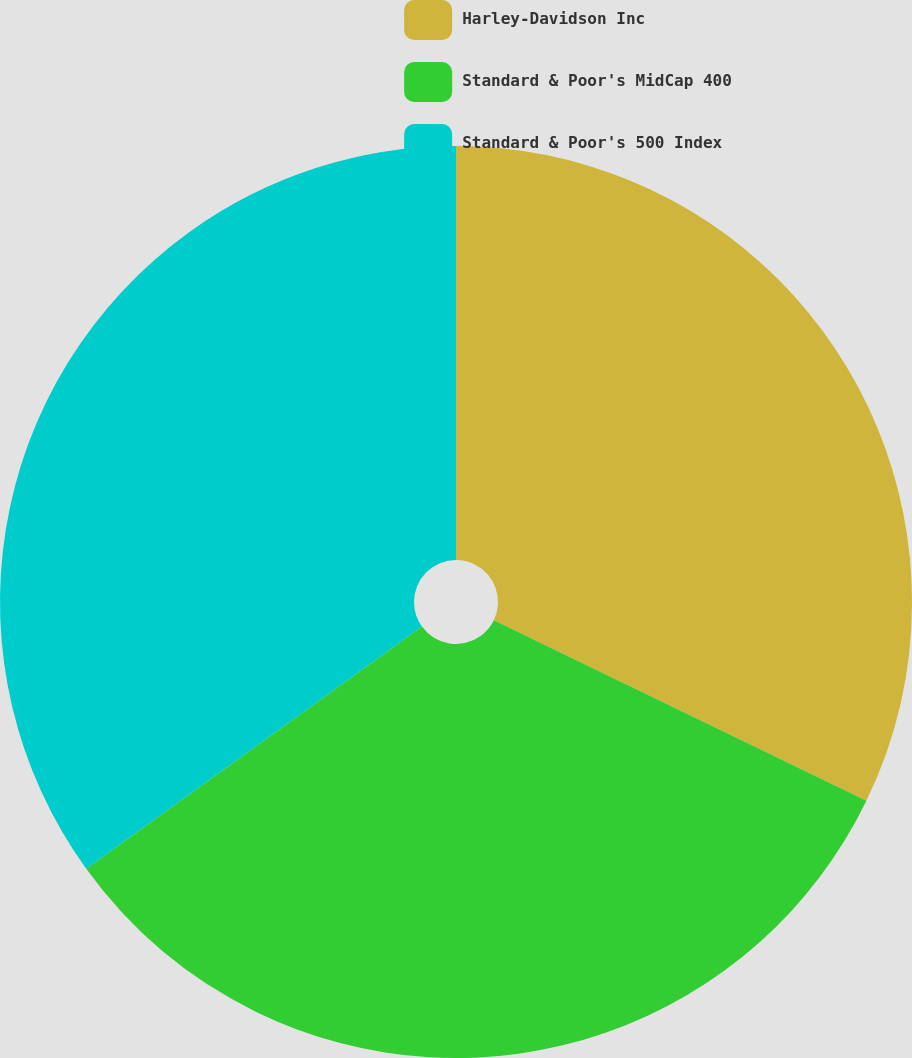<chart> <loc_0><loc_0><loc_500><loc_500><pie_chart><fcel>Harley-Davidson Inc<fcel>Standard & Poor's MidCap 400<fcel>Standard & Poor's 500 Index<nl><fcel>32.18%<fcel>32.87%<fcel>34.95%<nl></chart> 